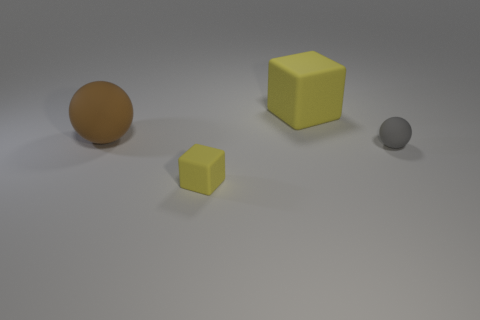Does the tiny matte cube have the same color as the large matte block?
Offer a very short reply. Yes. Are there any gray metal cubes that have the same size as the brown sphere?
Your answer should be compact. No. Is the color of the large cube the same as the block in front of the big sphere?
Your response must be concise. Yes. What is the brown thing made of?
Ensure brevity in your answer.  Rubber. What is the color of the tiny object behind the tiny yellow matte block?
Offer a terse response. Gray. How many small matte things have the same color as the big cube?
Keep it short and to the point. 1. What number of rubber things are on the right side of the small block and behind the small gray matte ball?
Give a very brief answer. 1. What is the size of the brown object?
Offer a terse response. Large. What color is the large ball that is the same material as the small ball?
Offer a very short reply. Brown. There is a big yellow block that is behind the small thing in front of the small gray sphere; how many large rubber things are to the left of it?
Keep it short and to the point. 1. 